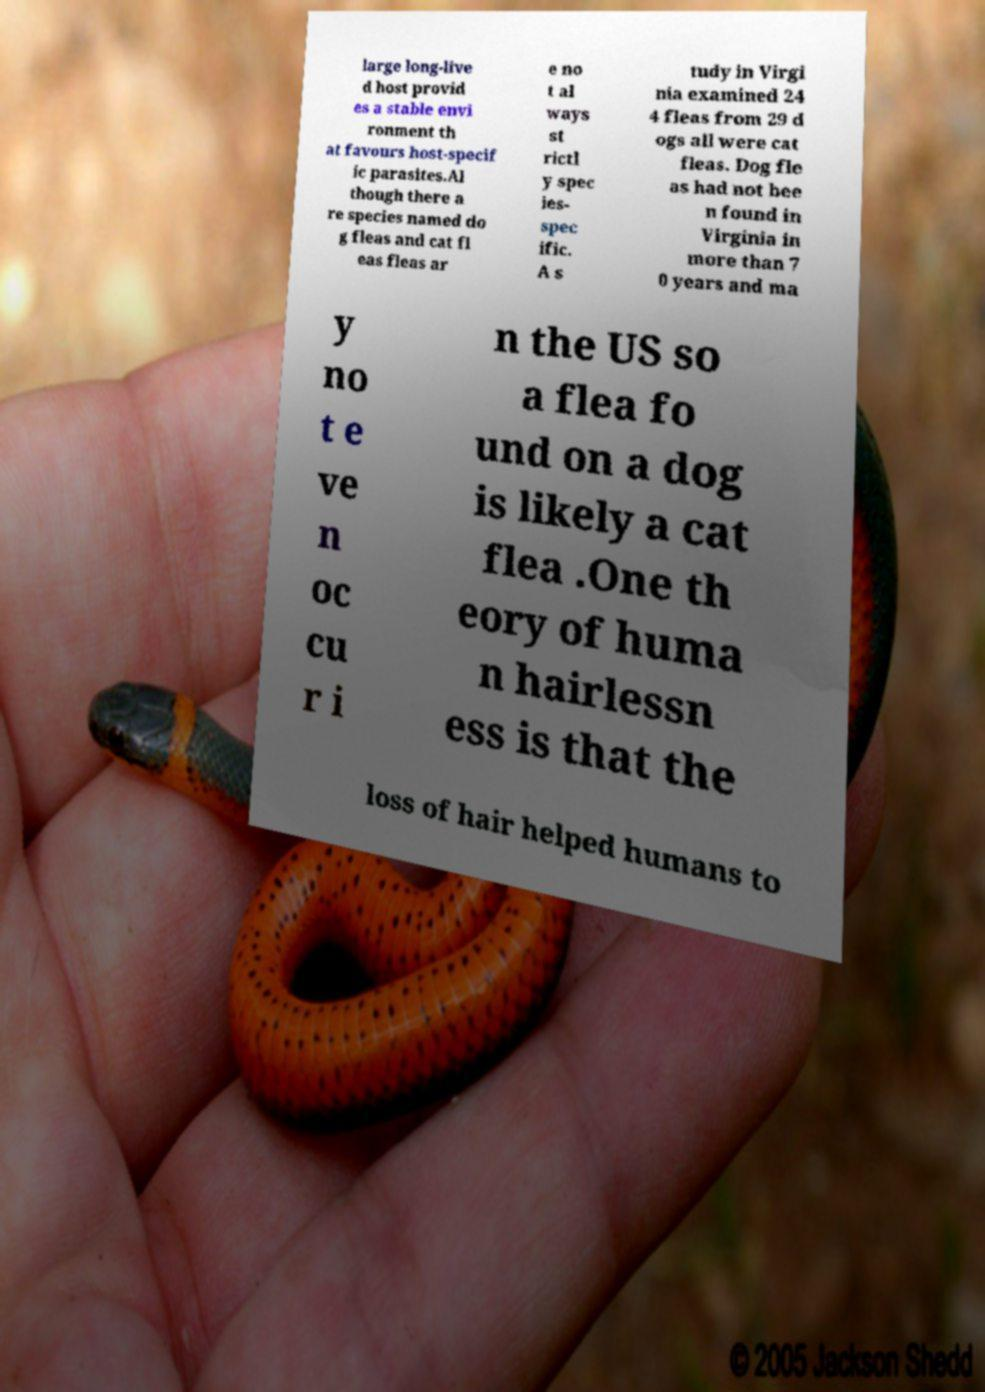Could you assist in decoding the text presented in this image and type it out clearly? large long-live d host provid es a stable envi ronment th at favours host-specif ic parasites.Al though there a re species named do g fleas and cat fl eas fleas ar e no t al ways st rictl y spec ies- spec ific. A s tudy in Virgi nia examined 24 4 fleas from 29 d ogs all were cat fleas. Dog fle as had not bee n found in Virginia in more than 7 0 years and ma y no t e ve n oc cu r i n the US so a flea fo und on a dog is likely a cat flea .One th eory of huma n hairlessn ess is that the loss of hair helped humans to 